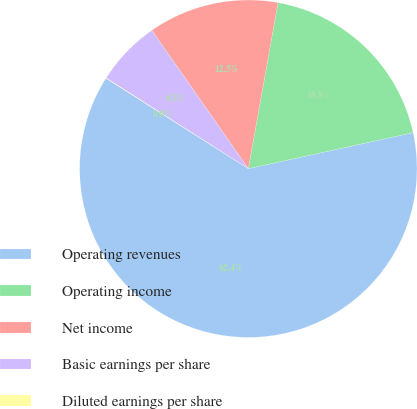Convert chart to OTSL. <chart><loc_0><loc_0><loc_500><loc_500><pie_chart><fcel>Operating revenues<fcel>Operating income<fcel>Net income<fcel>Basic earnings per share<fcel>Diluted earnings per share<nl><fcel>62.44%<fcel>18.75%<fcel>12.51%<fcel>6.27%<fcel>0.03%<nl></chart> 